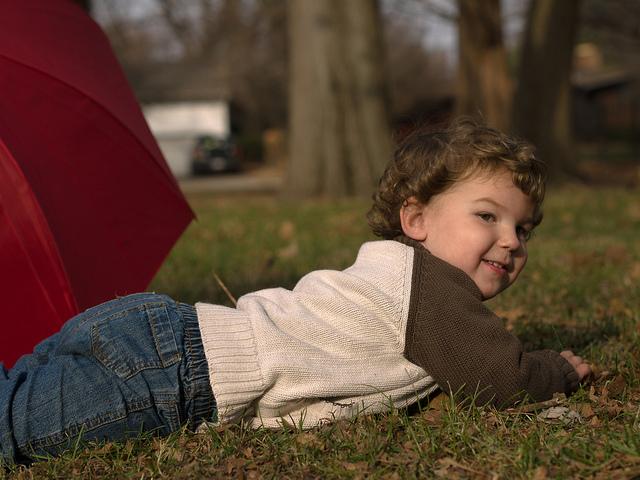Could the child  have on shoes?
Be succinct. Yes. Is there a tree in the background?
Keep it brief. Yes. What is the boy holding?
Write a very short answer. Grass. Is the baby cute?
Keep it brief. Yes. 